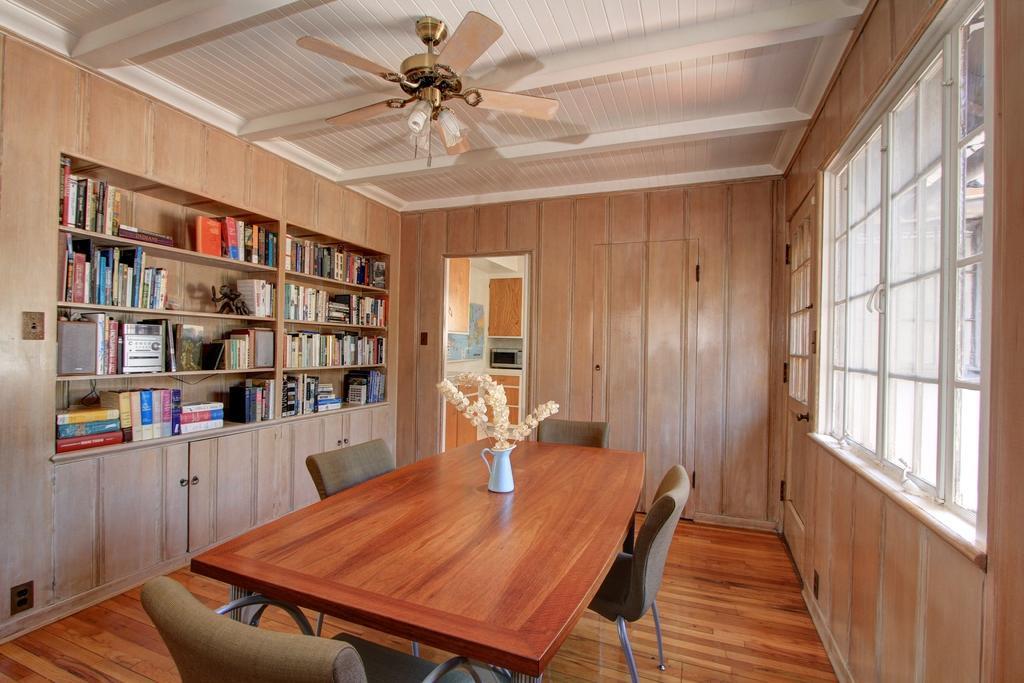How would you summarize this image in a sentence or two? In this image there is a table with a flower pot on it and there are chairs. On the left side of the image there are books and other objects are arranged on the shelves. On the right side of the image there is a glass window and a glass door. In the background there is like a door and a wall. At the top of the image there is a ceiling with a fan. 